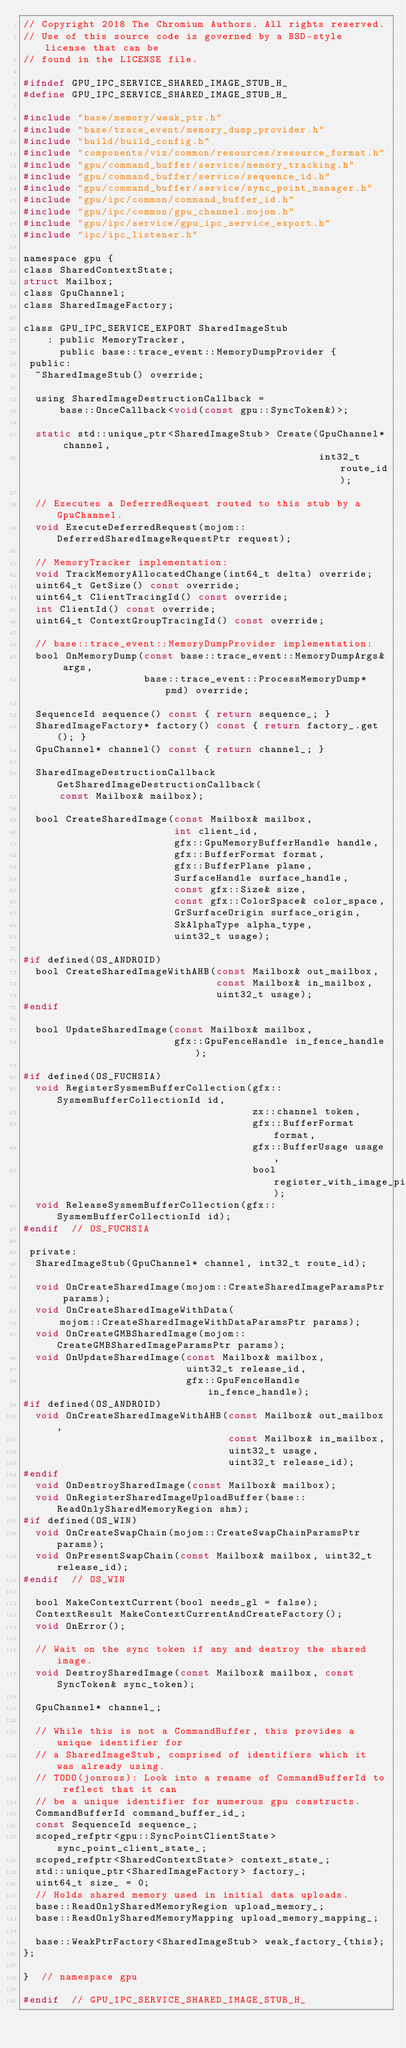<code> <loc_0><loc_0><loc_500><loc_500><_C_>// Copyright 2018 The Chromium Authors. All rights reserved.
// Use of this source code is governed by a BSD-style license that can be
// found in the LICENSE file.

#ifndef GPU_IPC_SERVICE_SHARED_IMAGE_STUB_H_
#define GPU_IPC_SERVICE_SHARED_IMAGE_STUB_H_

#include "base/memory/weak_ptr.h"
#include "base/trace_event/memory_dump_provider.h"
#include "build/build_config.h"
#include "components/viz/common/resources/resource_format.h"
#include "gpu/command_buffer/service/memory_tracking.h"
#include "gpu/command_buffer/service/sequence_id.h"
#include "gpu/command_buffer/service/sync_point_manager.h"
#include "gpu/ipc/common/command_buffer_id.h"
#include "gpu/ipc/common/gpu_channel.mojom.h"
#include "gpu/ipc/service/gpu_ipc_service_export.h"
#include "ipc/ipc_listener.h"

namespace gpu {
class SharedContextState;
struct Mailbox;
class GpuChannel;
class SharedImageFactory;

class GPU_IPC_SERVICE_EXPORT SharedImageStub
    : public MemoryTracker,
      public base::trace_event::MemoryDumpProvider {
 public:
  ~SharedImageStub() override;

  using SharedImageDestructionCallback =
      base::OnceCallback<void(const gpu::SyncToken&)>;

  static std::unique_ptr<SharedImageStub> Create(GpuChannel* channel,
                                                 int32_t route_id);

  // Executes a DeferredRequest routed to this stub by a GpuChannel.
  void ExecuteDeferredRequest(mojom::DeferredSharedImageRequestPtr request);

  // MemoryTracker implementation:
  void TrackMemoryAllocatedChange(int64_t delta) override;
  uint64_t GetSize() const override;
  uint64_t ClientTracingId() const override;
  int ClientId() const override;
  uint64_t ContextGroupTracingId() const override;

  // base::trace_event::MemoryDumpProvider implementation:
  bool OnMemoryDump(const base::trace_event::MemoryDumpArgs& args,
                    base::trace_event::ProcessMemoryDump* pmd) override;

  SequenceId sequence() const { return sequence_; }
  SharedImageFactory* factory() const { return factory_.get(); }
  GpuChannel* channel() const { return channel_; }

  SharedImageDestructionCallback GetSharedImageDestructionCallback(
      const Mailbox& mailbox);

  bool CreateSharedImage(const Mailbox& mailbox,
                         int client_id,
                         gfx::GpuMemoryBufferHandle handle,
                         gfx::BufferFormat format,
                         gfx::BufferPlane plane,
                         SurfaceHandle surface_handle,
                         const gfx::Size& size,
                         const gfx::ColorSpace& color_space,
                         GrSurfaceOrigin surface_origin,
                         SkAlphaType alpha_type,
                         uint32_t usage);

#if defined(OS_ANDROID)
  bool CreateSharedImageWithAHB(const Mailbox& out_mailbox,
                                const Mailbox& in_mailbox,
                                uint32_t usage);
#endif

  bool UpdateSharedImage(const Mailbox& mailbox,
                         gfx::GpuFenceHandle in_fence_handle);

#if defined(OS_FUCHSIA)
  void RegisterSysmemBufferCollection(gfx::SysmemBufferCollectionId id,
                                      zx::channel token,
                                      gfx::BufferFormat format,
                                      gfx::BufferUsage usage,
                                      bool register_with_image_pipe);
  void ReleaseSysmemBufferCollection(gfx::SysmemBufferCollectionId id);
#endif  // OS_FUCHSIA

 private:
  SharedImageStub(GpuChannel* channel, int32_t route_id);

  void OnCreateSharedImage(mojom::CreateSharedImageParamsPtr params);
  void OnCreateSharedImageWithData(
      mojom::CreateSharedImageWithDataParamsPtr params);
  void OnCreateGMBSharedImage(mojom::CreateGMBSharedImageParamsPtr params);
  void OnUpdateSharedImage(const Mailbox& mailbox,
                           uint32_t release_id,
                           gfx::GpuFenceHandle in_fence_handle);
#if defined(OS_ANDROID)
  void OnCreateSharedImageWithAHB(const Mailbox& out_mailbox,
                                  const Mailbox& in_mailbox,
                                  uint32_t usage,
                                  uint32_t release_id);
#endif
  void OnDestroySharedImage(const Mailbox& mailbox);
  void OnRegisterSharedImageUploadBuffer(base::ReadOnlySharedMemoryRegion shm);
#if defined(OS_WIN)
  void OnCreateSwapChain(mojom::CreateSwapChainParamsPtr params);
  void OnPresentSwapChain(const Mailbox& mailbox, uint32_t release_id);
#endif  // OS_WIN

  bool MakeContextCurrent(bool needs_gl = false);
  ContextResult MakeContextCurrentAndCreateFactory();
  void OnError();

  // Wait on the sync token if any and destroy the shared image.
  void DestroySharedImage(const Mailbox& mailbox, const SyncToken& sync_token);

  GpuChannel* channel_;

  // While this is not a CommandBuffer, this provides a unique identifier for
  // a SharedImageStub, comprised of identifiers which it was already using.
  // TODO(jonross): Look into a rename of CommandBufferId to reflect that it can
  // be a unique identifier for numerous gpu constructs.
  CommandBufferId command_buffer_id_;
  const SequenceId sequence_;
  scoped_refptr<gpu::SyncPointClientState> sync_point_client_state_;
  scoped_refptr<SharedContextState> context_state_;
  std::unique_ptr<SharedImageFactory> factory_;
  uint64_t size_ = 0;
  // Holds shared memory used in initial data uploads.
  base::ReadOnlySharedMemoryRegion upload_memory_;
  base::ReadOnlySharedMemoryMapping upload_memory_mapping_;

  base::WeakPtrFactory<SharedImageStub> weak_factory_{this};
};

}  // namespace gpu

#endif  // GPU_IPC_SERVICE_SHARED_IMAGE_STUB_H_
</code> 